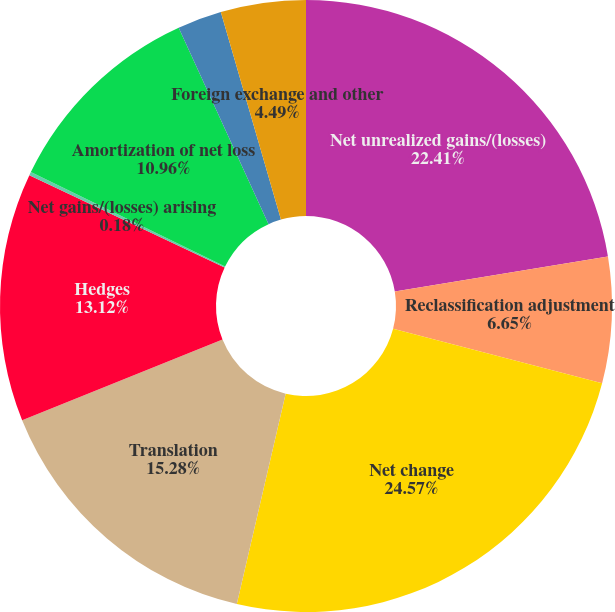Convert chart to OTSL. <chart><loc_0><loc_0><loc_500><loc_500><pie_chart><fcel>Net unrealized gains/(losses)<fcel>Reclassification adjustment<fcel>Net change<fcel>Translation<fcel>Hedges<fcel>Net gains/(losses) arising<fcel>Amortization of net loss<fcel>Prior service costs/(credits)<fcel>Foreign exchange and other<nl><fcel>22.41%<fcel>6.65%<fcel>24.57%<fcel>15.28%<fcel>13.12%<fcel>0.18%<fcel>10.96%<fcel>2.34%<fcel>4.49%<nl></chart> 